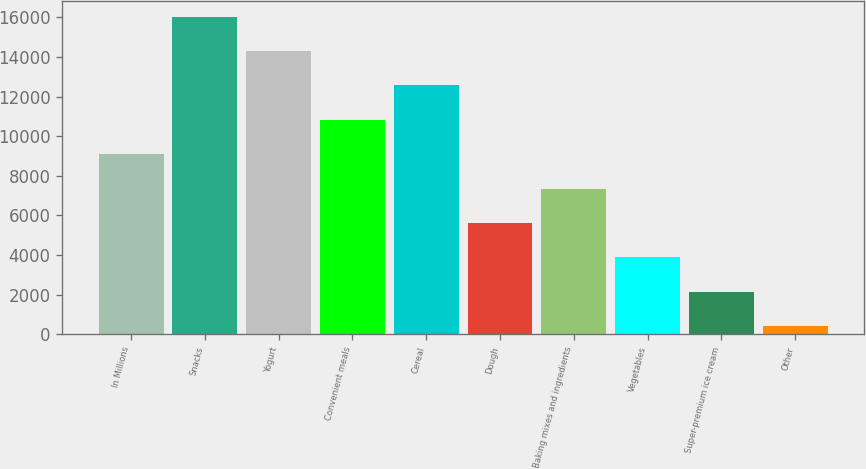Convert chart to OTSL. <chart><loc_0><loc_0><loc_500><loc_500><bar_chart><fcel>In Millions<fcel>Snacks<fcel>Yogurt<fcel>Convenient meals<fcel>Cereal<fcel>Dough<fcel>Baking mixes and ingredients<fcel>Vegetables<fcel>Super-premium ice cream<fcel>Other<nl><fcel>9086.45<fcel>16036.6<fcel>14299<fcel>10824<fcel>12561.5<fcel>5611.39<fcel>7348.92<fcel>3873.86<fcel>2136.33<fcel>398.8<nl></chart> 